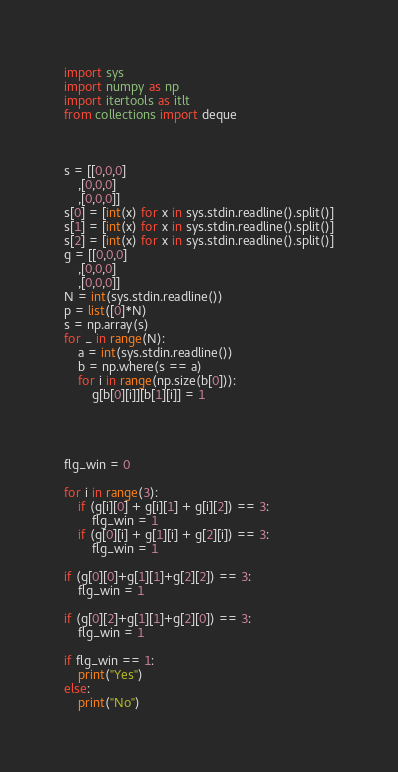<code> <loc_0><loc_0><loc_500><loc_500><_Python_>
import sys
import numpy as np
import itertools as itlt
from collections import deque
 

 
s = [[0,0,0]
    ,[0,0,0]
    ,[0,0,0]]    
s[0] = [int(x) for x in sys.stdin.readline().split()]
s[1] = [int(x) for x in sys.stdin.readline().split()]
s[2] = [int(x) for x in sys.stdin.readline().split()]
g = [[0,0,0]
    ,[0,0,0]
    ,[0,0,0]]
N = int(sys.stdin.readline())
p = list([0]*N)
s = np.array(s)
for _ in range(N):
    a = int(sys.stdin.readline())
    b = np.where(s == a)
    for i in range(np.size(b[0])):
        g[b[0][i]][b[1][i]] = 1
 

 
 
flg_win = 0
 
for i in range(3):
    if (g[i][0] + g[i][1] + g[i][2]) == 3:
        flg_win = 1
    if (g[0][i] + g[1][i] + g[2][i]) == 3:
        flg_win = 1
 
if (g[0][0]+g[1][1]+g[2][2]) == 3:
    flg_win = 1
 
if (g[0][2]+g[1][1]+g[2][0]) == 3:
    flg_win = 1
 
if flg_win == 1:
    print("Yes")
else:
    print("No")
</code> 